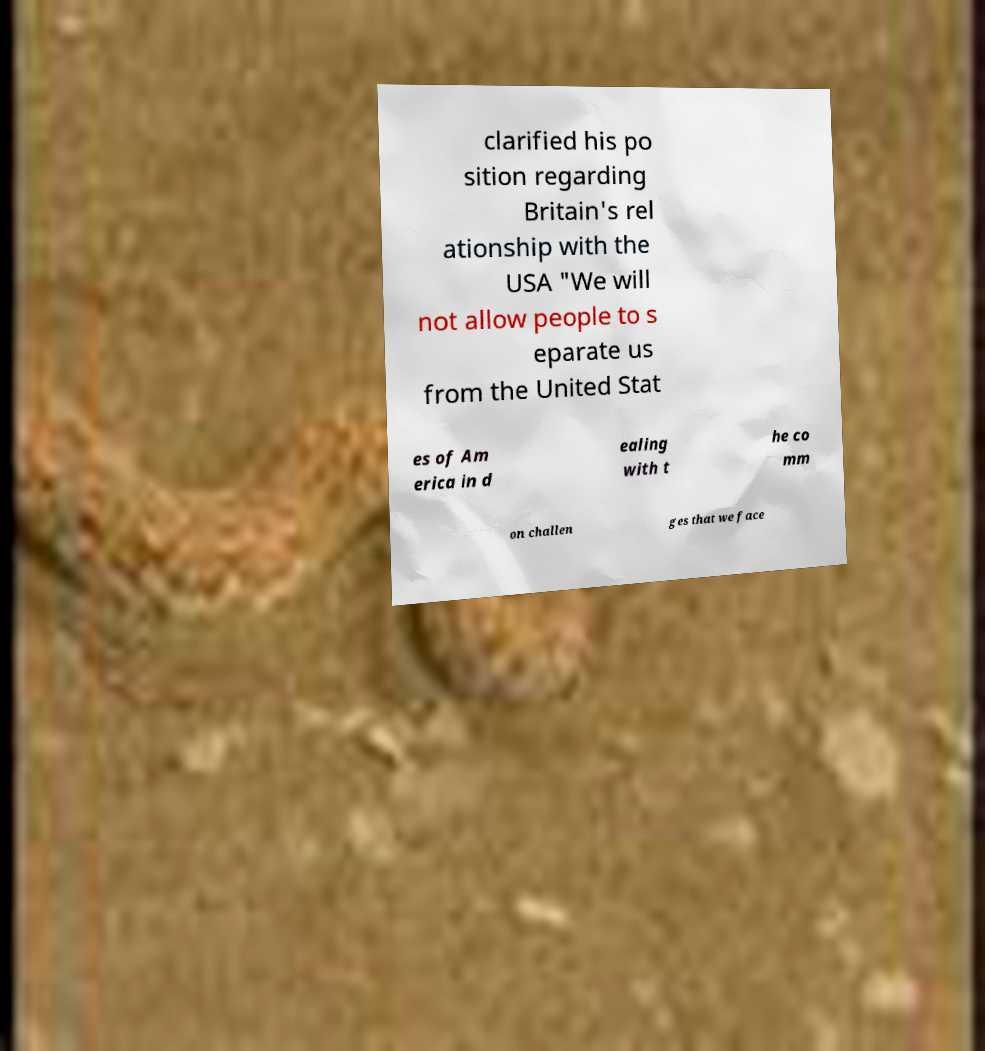Can you accurately transcribe the text from the provided image for me? clarified his po sition regarding Britain's rel ationship with the USA "We will not allow people to s eparate us from the United Stat es of Am erica in d ealing with t he co mm on challen ges that we face 